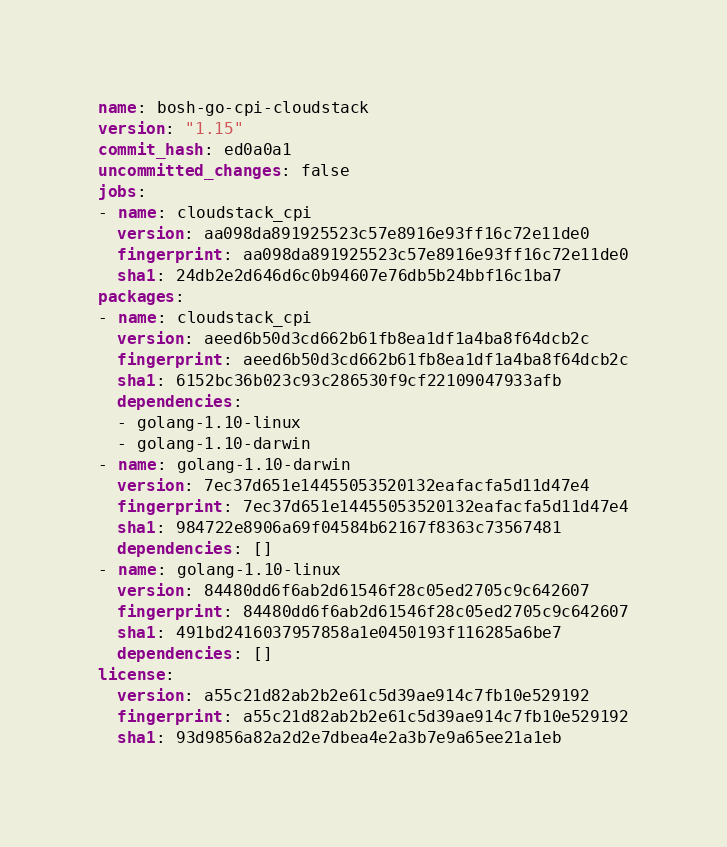Convert code to text. <code><loc_0><loc_0><loc_500><loc_500><_YAML_>name: bosh-go-cpi-cloudstack
version: "1.15"
commit_hash: ed0a0a1
uncommitted_changes: false
jobs:
- name: cloudstack_cpi
  version: aa098da891925523c57e8916e93ff16c72e11de0
  fingerprint: aa098da891925523c57e8916e93ff16c72e11de0
  sha1: 24db2e2d646d6c0b94607e76db5b24bbf16c1ba7
packages:
- name: cloudstack_cpi
  version: aeed6b50d3cd662b61fb8ea1df1a4ba8f64dcb2c
  fingerprint: aeed6b50d3cd662b61fb8ea1df1a4ba8f64dcb2c
  sha1: 6152bc36b023c93c286530f9cf22109047933afb
  dependencies:
  - golang-1.10-linux
  - golang-1.10-darwin
- name: golang-1.10-darwin
  version: 7ec37d651e14455053520132eafacfa5d11d47e4
  fingerprint: 7ec37d651e14455053520132eafacfa5d11d47e4
  sha1: 984722e8906a69f04584b62167f8363c73567481
  dependencies: []
- name: golang-1.10-linux
  version: 84480dd6f6ab2d61546f28c05ed2705c9c642607
  fingerprint: 84480dd6f6ab2d61546f28c05ed2705c9c642607
  sha1: 491bd2416037957858a1e0450193f116285a6be7
  dependencies: []
license:
  version: a55c21d82ab2b2e61c5d39ae914c7fb10e529192
  fingerprint: a55c21d82ab2b2e61c5d39ae914c7fb10e529192
  sha1: 93d9856a82a2d2e7dbea4e2a3b7e9a65ee21a1eb
</code> 